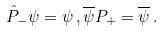Convert formula to latex. <formula><loc_0><loc_0><loc_500><loc_500>\hat { P } _ { - } \psi = \psi \, , \overline { \psi } P _ { + } = \overline { \psi } \, .</formula> 